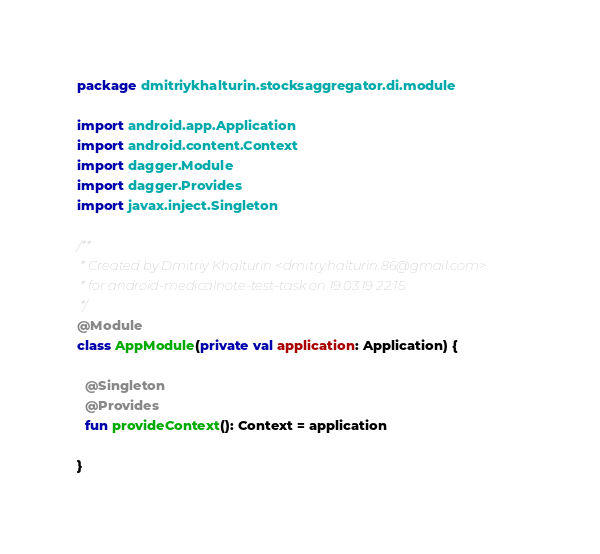Convert code to text. <code><loc_0><loc_0><loc_500><loc_500><_Kotlin_>package dmitriykhalturin.stocksaggregator.di.module

import android.app.Application
import android.content.Context
import dagger.Module
import dagger.Provides
import javax.inject.Singleton

/**
 * Created by Dmitriy Khalturin <dmitry.halturin.86@gmail.com>
 * for android-medicalnote-test-task on 19.03.19 22:15.
 */
@Module
class AppModule(private val application: Application) {

  @Singleton
  @Provides
  fun provideContext(): Context = application

}
</code> 